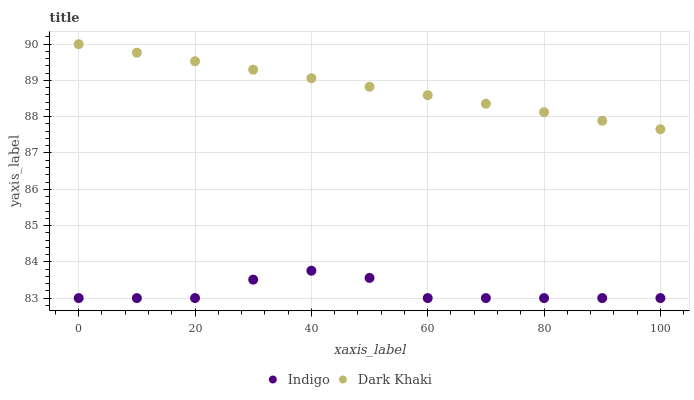Does Indigo have the minimum area under the curve?
Answer yes or no. Yes. Does Dark Khaki have the maximum area under the curve?
Answer yes or no. Yes. Does Indigo have the maximum area under the curve?
Answer yes or no. No. Is Dark Khaki the smoothest?
Answer yes or no. Yes. Is Indigo the roughest?
Answer yes or no. Yes. Is Indigo the smoothest?
Answer yes or no. No. Does Indigo have the lowest value?
Answer yes or no. Yes. Does Dark Khaki have the highest value?
Answer yes or no. Yes. Does Indigo have the highest value?
Answer yes or no. No. Is Indigo less than Dark Khaki?
Answer yes or no. Yes. Is Dark Khaki greater than Indigo?
Answer yes or no. Yes. Does Indigo intersect Dark Khaki?
Answer yes or no. No. 